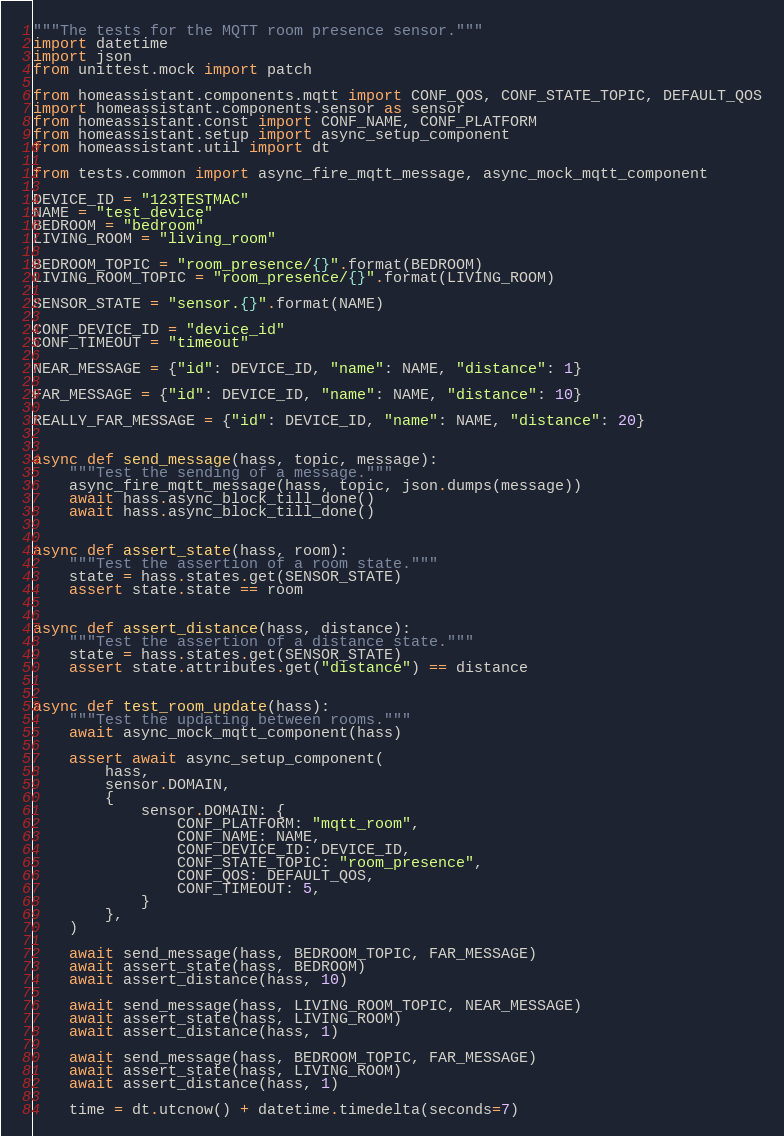<code> <loc_0><loc_0><loc_500><loc_500><_Python_>"""The tests for the MQTT room presence sensor."""
import datetime
import json
from unittest.mock import patch

from homeassistant.components.mqtt import CONF_QOS, CONF_STATE_TOPIC, DEFAULT_QOS
import homeassistant.components.sensor as sensor
from homeassistant.const import CONF_NAME, CONF_PLATFORM
from homeassistant.setup import async_setup_component
from homeassistant.util import dt

from tests.common import async_fire_mqtt_message, async_mock_mqtt_component

DEVICE_ID = "123TESTMAC"
NAME = "test_device"
BEDROOM = "bedroom"
LIVING_ROOM = "living_room"

BEDROOM_TOPIC = "room_presence/{}".format(BEDROOM)
LIVING_ROOM_TOPIC = "room_presence/{}".format(LIVING_ROOM)

SENSOR_STATE = "sensor.{}".format(NAME)

CONF_DEVICE_ID = "device_id"
CONF_TIMEOUT = "timeout"

NEAR_MESSAGE = {"id": DEVICE_ID, "name": NAME, "distance": 1}

FAR_MESSAGE = {"id": DEVICE_ID, "name": NAME, "distance": 10}

REALLY_FAR_MESSAGE = {"id": DEVICE_ID, "name": NAME, "distance": 20}


async def send_message(hass, topic, message):
    """Test the sending of a message."""
    async_fire_mqtt_message(hass, topic, json.dumps(message))
    await hass.async_block_till_done()
    await hass.async_block_till_done()


async def assert_state(hass, room):
    """Test the assertion of a room state."""
    state = hass.states.get(SENSOR_STATE)
    assert state.state == room


async def assert_distance(hass, distance):
    """Test the assertion of a distance state."""
    state = hass.states.get(SENSOR_STATE)
    assert state.attributes.get("distance") == distance


async def test_room_update(hass):
    """Test the updating between rooms."""
    await async_mock_mqtt_component(hass)

    assert await async_setup_component(
        hass,
        sensor.DOMAIN,
        {
            sensor.DOMAIN: {
                CONF_PLATFORM: "mqtt_room",
                CONF_NAME: NAME,
                CONF_DEVICE_ID: DEVICE_ID,
                CONF_STATE_TOPIC: "room_presence",
                CONF_QOS: DEFAULT_QOS,
                CONF_TIMEOUT: 5,
            }
        },
    )

    await send_message(hass, BEDROOM_TOPIC, FAR_MESSAGE)
    await assert_state(hass, BEDROOM)
    await assert_distance(hass, 10)

    await send_message(hass, LIVING_ROOM_TOPIC, NEAR_MESSAGE)
    await assert_state(hass, LIVING_ROOM)
    await assert_distance(hass, 1)

    await send_message(hass, BEDROOM_TOPIC, FAR_MESSAGE)
    await assert_state(hass, LIVING_ROOM)
    await assert_distance(hass, 1)

    time = dt.utcnow() + datetime.timedelta(seconds=7)</code> 